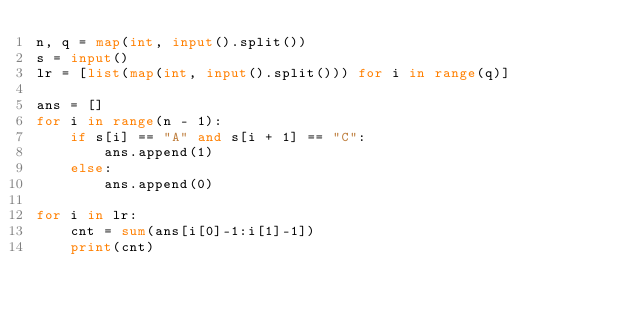<code> <loc_0><loc_0><loc_500><loc_500><_Python_>n, q = map(int, input().split())
s = input()
lr = [list(map(int, input().split())) for i in range(q)]

ans = []
for i in range(n - 1):
    if s[i] == "A" and s[i + 1] == "C":
        ans.append(1)
    else:
        ans.append(0)

for i in lr:
    cnt = sum(ans[i[0]-1:i[1]-1])
    print(cnt)</code> 